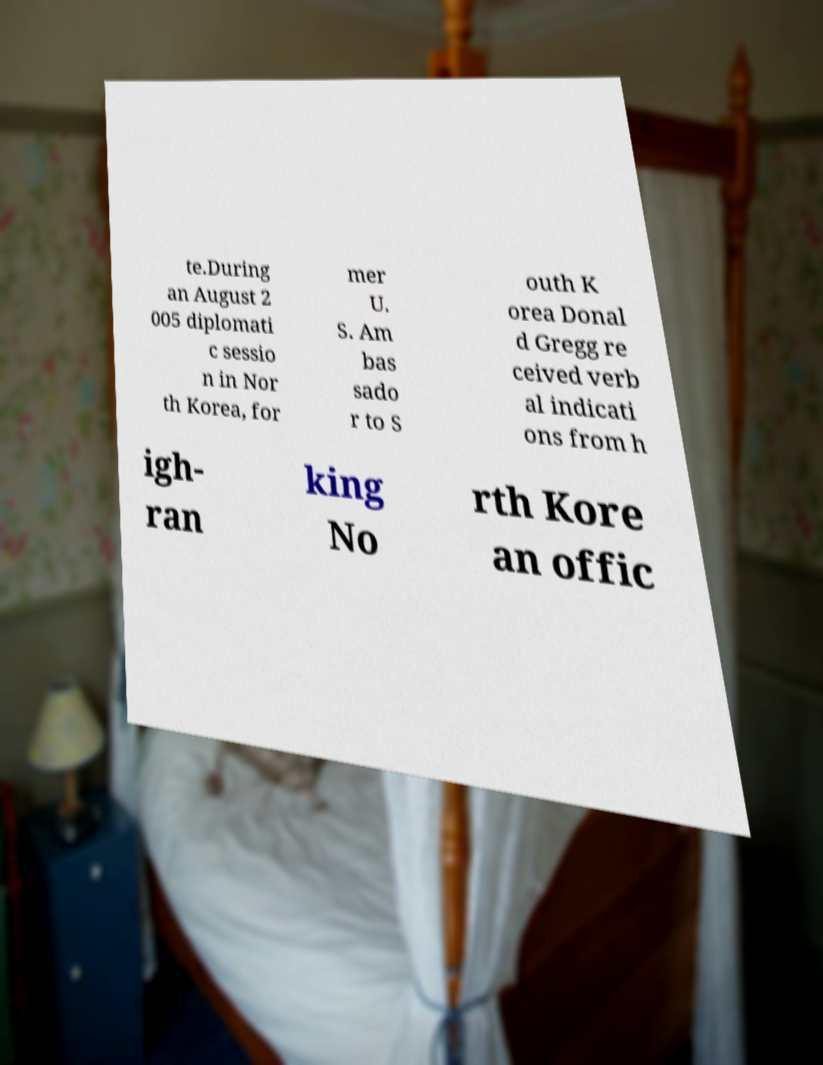Can you read and provide the text displayed in the image?This photo seems to have some interesting text. Can you extract and type it out for me? te.During an August 2 005 diplomati c sessio n in Nor th Korea, for mer U. S. Am bas sado r to S outh K orea Donal d Gregg re ceived verb al indicati ons from h igh- ran king No rth Kore an offic 